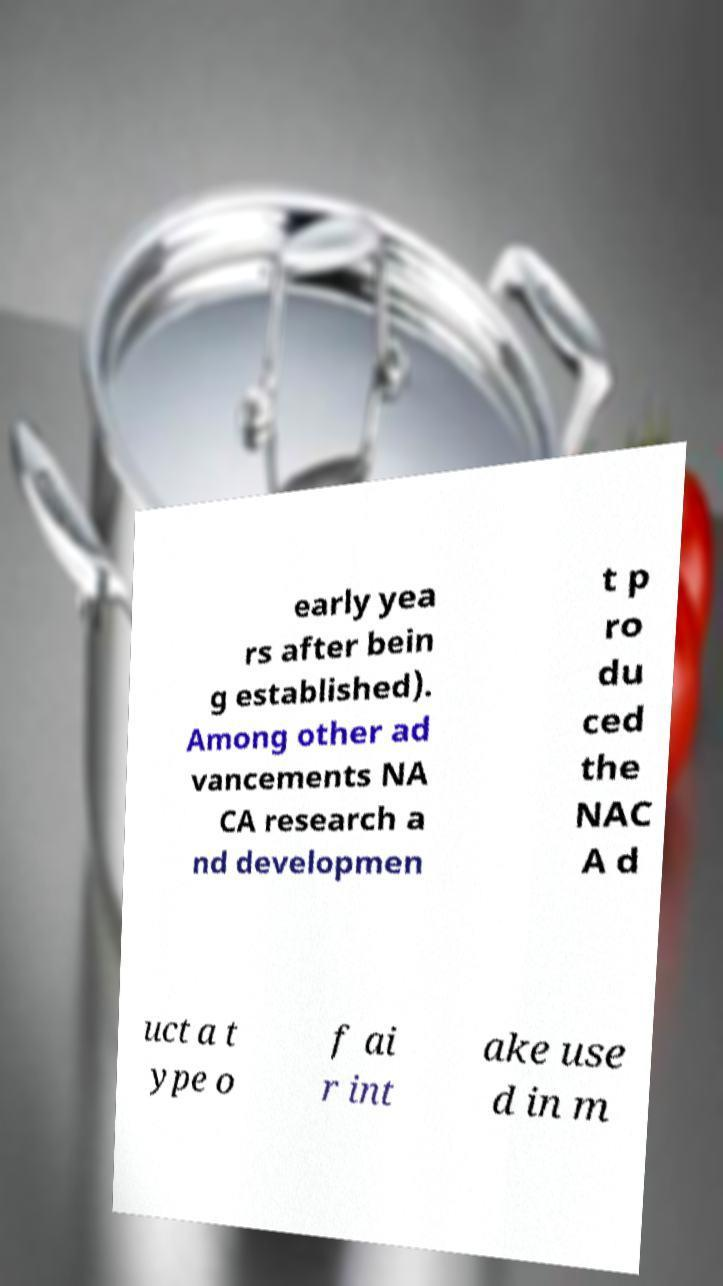Could you extract and type out the text from this image? early yea rs after bein g established). Among other ad vancements NA CA research a nd developmen t p ro du ced the NAC A d uct a t ype o f ai r int ake use d in m 